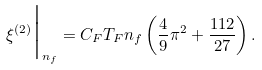<formula> <loc_0><loc_0><loc_500><loc_500>\xi ^ { ( 2 ) } \Big | _ { n _ { f } } = C _ { F } T _ { F } n _ { f } \left ( \frac { 4 } { 9 } \pi ^ { 2 } + \frac { 1 1 2 } { 2 7 } \right ) .</formula> 